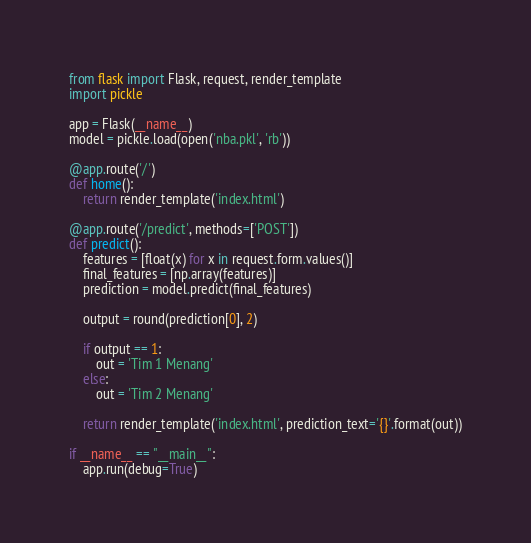Convert code to text. <code><loc_0><loc_0><loc_500><loc_500><_Python_>from flask import Flask, request, render_template
import pickle

app = Flask(__name__)
model = pickle.load(open('nba.pkl', 'rb'))

@app.route('/')
def home():
    return render_template('index.html')

@app.route('/predict', methods=['POST'])
def predict():
    features = [float(x) for x in request.form.values()]
    final_features = [np.array(features)]
    prediction = model.predict(final_features)

    output = round(prediction[0], 2)

    if output == 1:
        out = 'Tim 1 Menang'
    else:
        out = 'Tim 2 Menang'

    return render_template('index.html', prediction_text='{}'.format(out))

if __name__ == "__main__":
    app.run(debug=True)</code> 